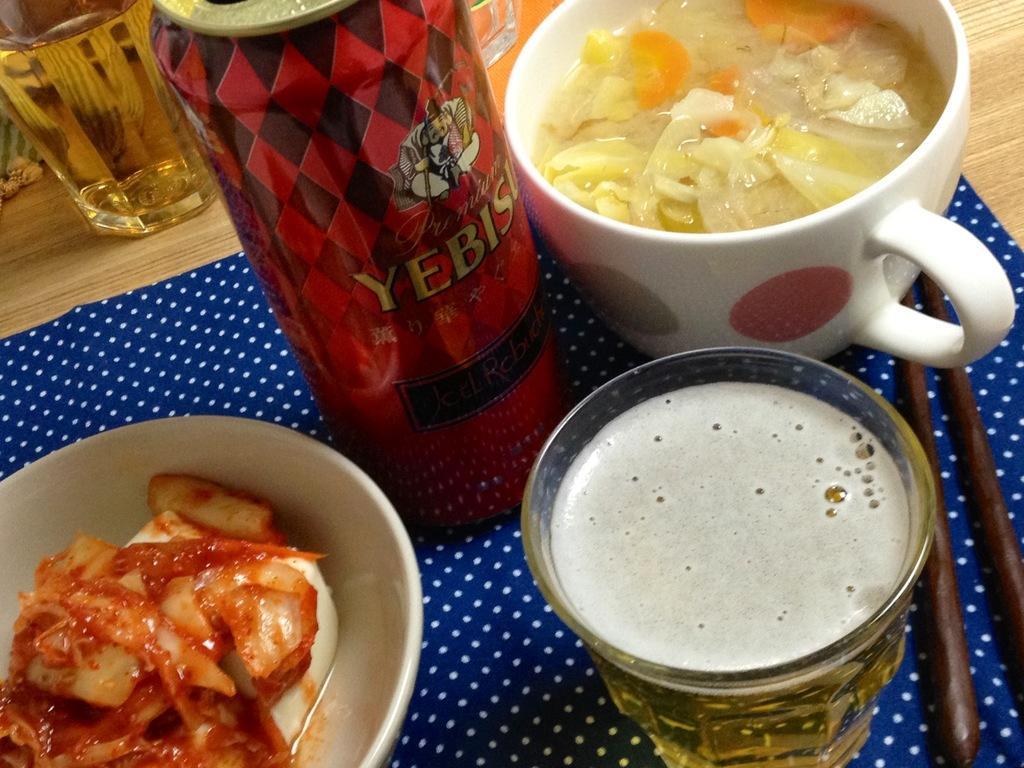Please provide a concise description of this image. This is a zoomed in picture. In the center we can see the red color can, glasses of drinks and some food items are placed on the top of the wooden table and we can see the chopsticks and some other items. 